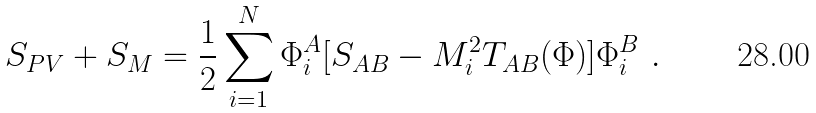<formula> <loc_0><loc_0><loc_500><loc_500>S _ { P V } + S _ { M } = \frac { 1 } { 2 } \sum _ { i = 1 } ^ { N } \Phi ^ { A } _ { i } [ S _ { A B } - M ^ { 2 } _ { i } T _ { A B } ( \Phi ) ] \Phi ^ { B } _ { i } \ .</formula> 